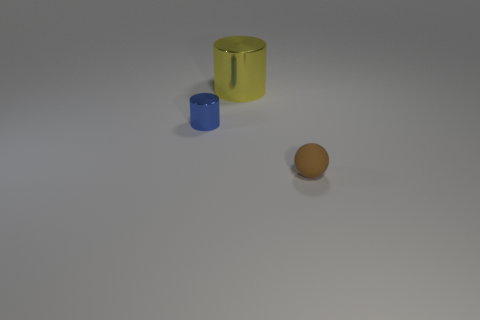There is another thing that is the same shape as the yellow metal object; what is its size?
Your answer should be compact. Small. Are there any other things that have the same size as the brown rubber sphere?
Provide a short and direct response. Yes. The object that is to the left of the metallic object to the right of the small thing behind the matte ball is made of what material?
Give a very brief answer. Metal. Are there more big yellow things that are in front of the brown matte sphere than shiny cylinders right of the blue cylinder?
Your answer should be compact. No. Is the blue metallic thing the same size as the brown thing?
Your response must be concise. Yes. The other object that is the same shape as the big yellow shiny object is what color?
Offer a terse response. Blue. Are there more small cylinders that are on the left side of the small rubber object than large brown things?
Provide a short and direct response. Yes. What is the color of the metal object behind the metal cylinder that is on the left side of the large yellow shiny object?
Offer a terse response. Yellow. What number of objects are either tiny things that are behind the tiny matte thing or objects to the left of the small brown rubber sphere?
Provide a short and direct response. 2. The tiny metallic object has what color?
Give a very brief answer. Blue. 